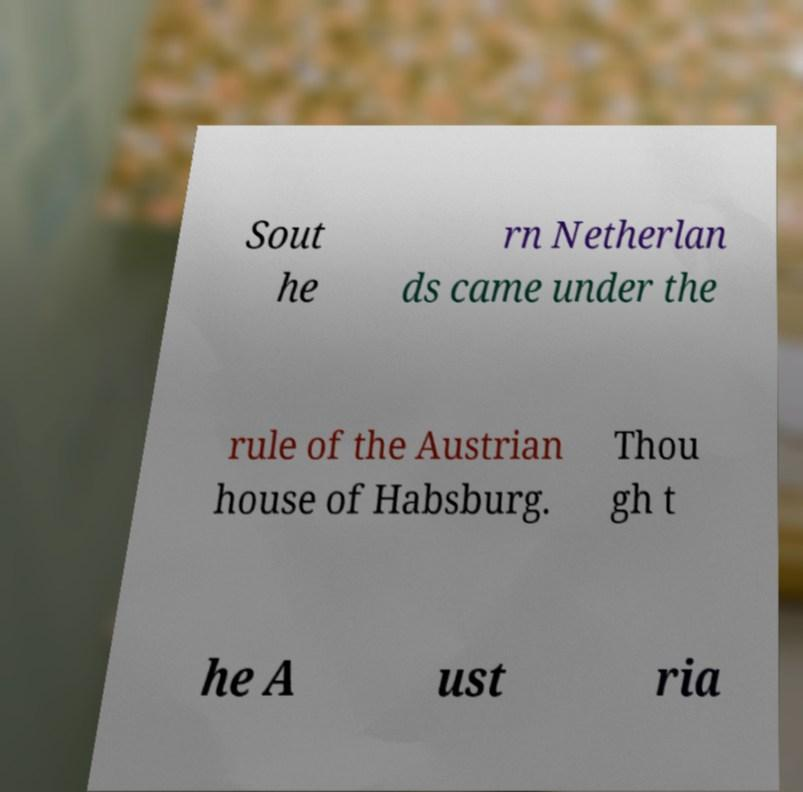I need the written content from this picture converted into text. Can you do that? Sout he rn Netherlan ds came under the rule of the Austrian house of Habsburg. Thou gh t he A ust ria 